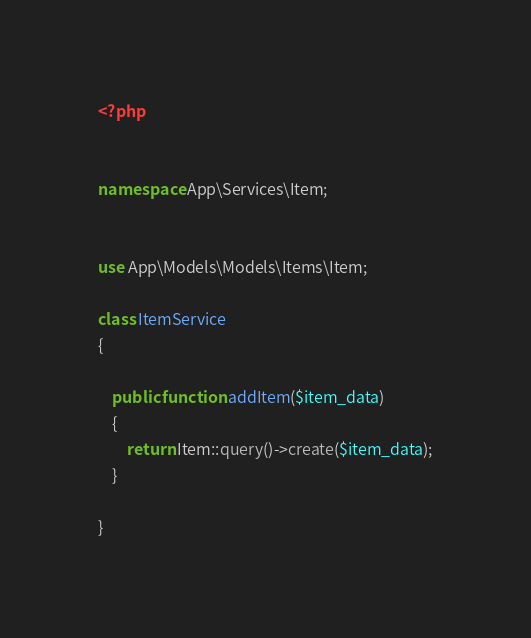<code> <loc_0><loc_0><loc_500><loc_500><_PHP_><?php


namespace App\Services\Item;


use App\Models\Models\Items\Item;

class ItemService
{

    public function addItem($item_data)
    {
        return Item::query()->create($item_data);
    }

}
</code> 